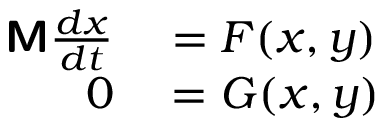<formula> <loc_0><loc_0><loc_500><loc_500>\begin{array} { r l } { M \frac { d x } { d t } } & = F ( x , y ) } \\ { 0 } & = G ( x , y ) } \end{array}</formula> 